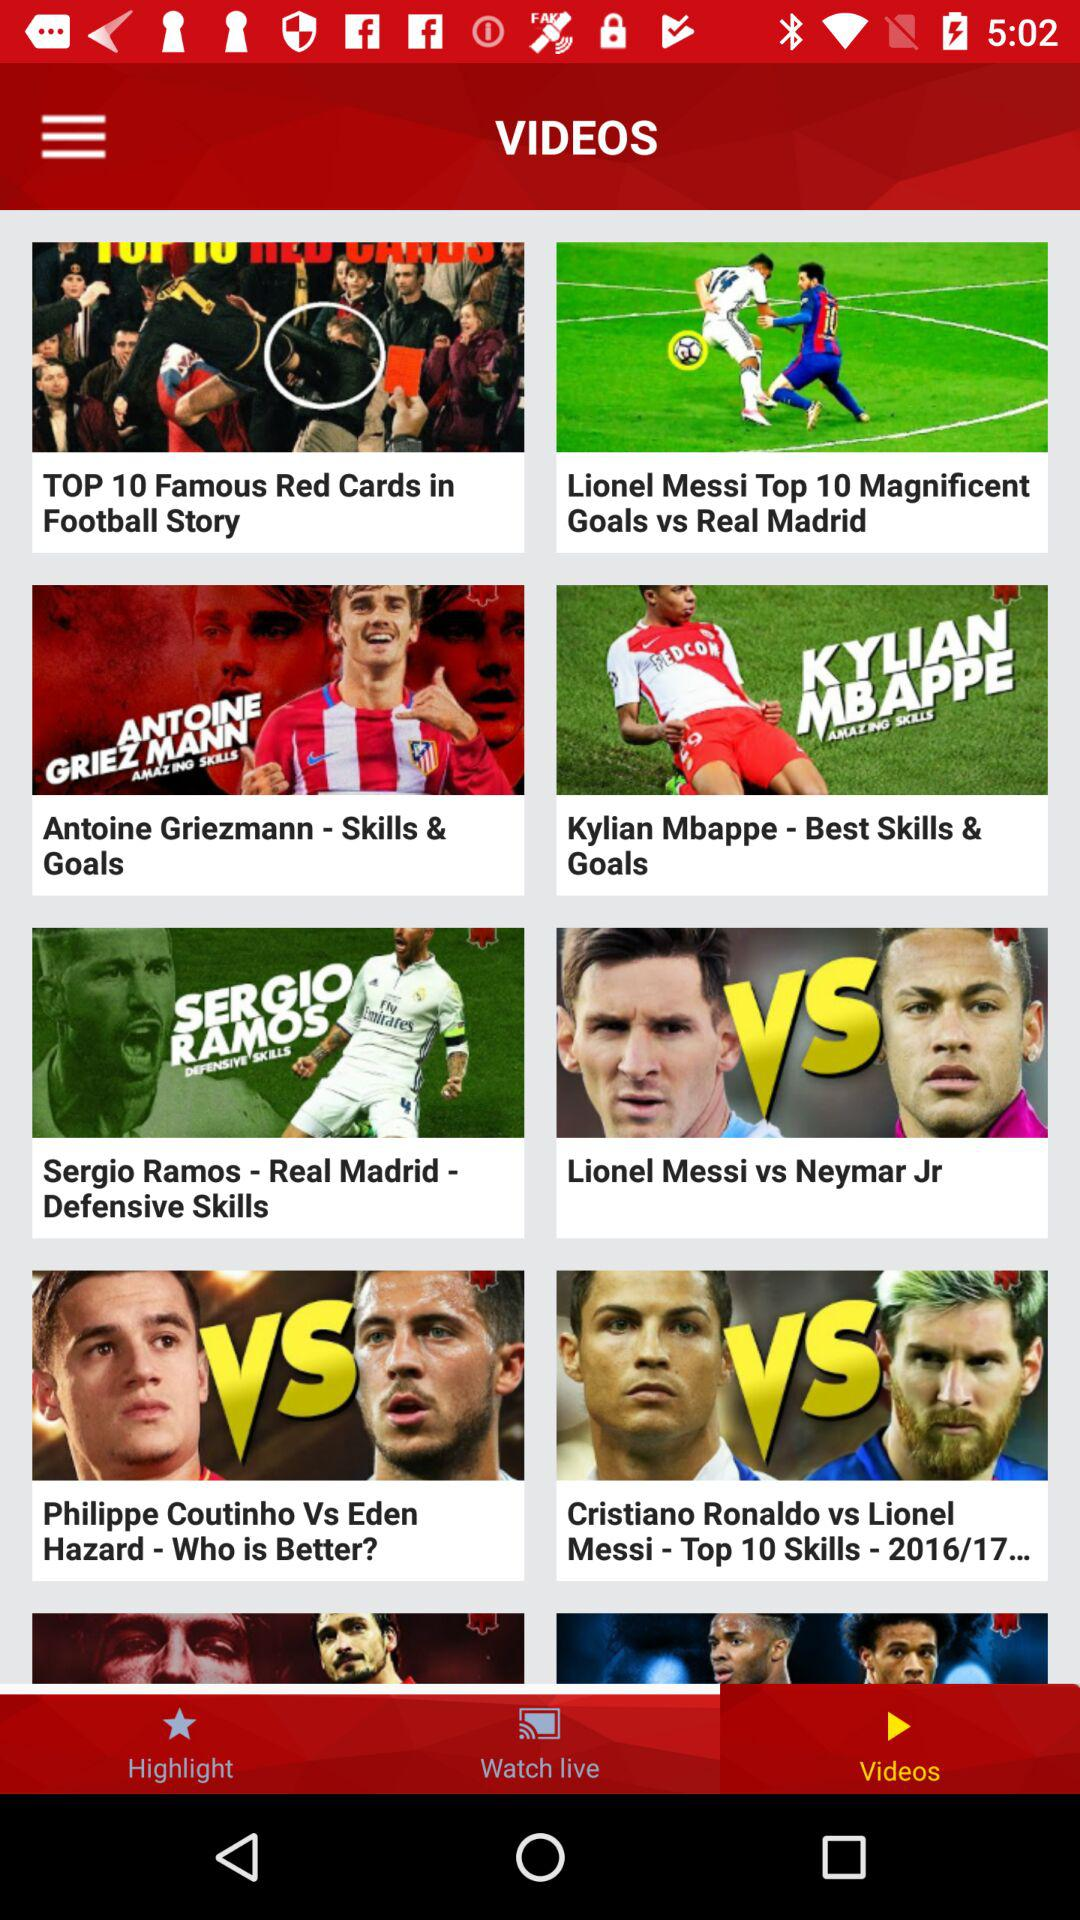Which tab am I using? You are using the "Videos" tab. 